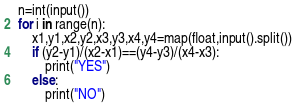Convert code to text. <code><loc_0><loc_0><loc_500><loc_500><_Python_>n=int(input())
for i in range(n):
    x1,y1,x2,y2,x3,y3,x4,y4=map(float,input().split())
    if (y2-y1)/(x2-x1)==(y4-y3)/(x4-x3):
        print("YES")
    else:
        print("NO")</code> 